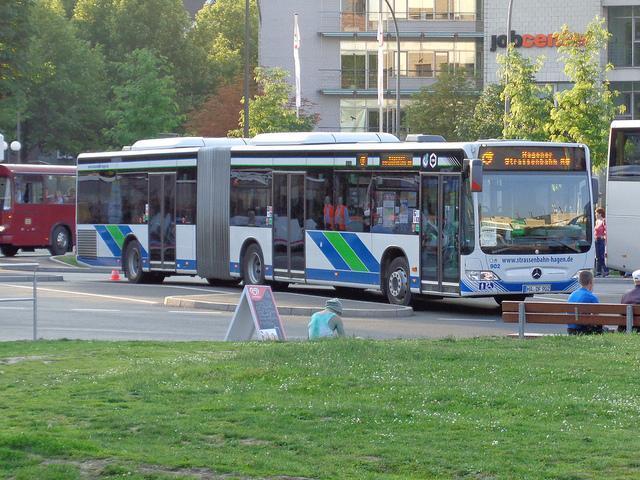How many people are sitting on the ground?
Give a very brief answer. 1. How many people are sitting on a bench?
Give a very brief answer. 2. How many buses are in the picture?
Give a very brief answer. 3. How many birds are here?
Give a very brief answer. 0. 